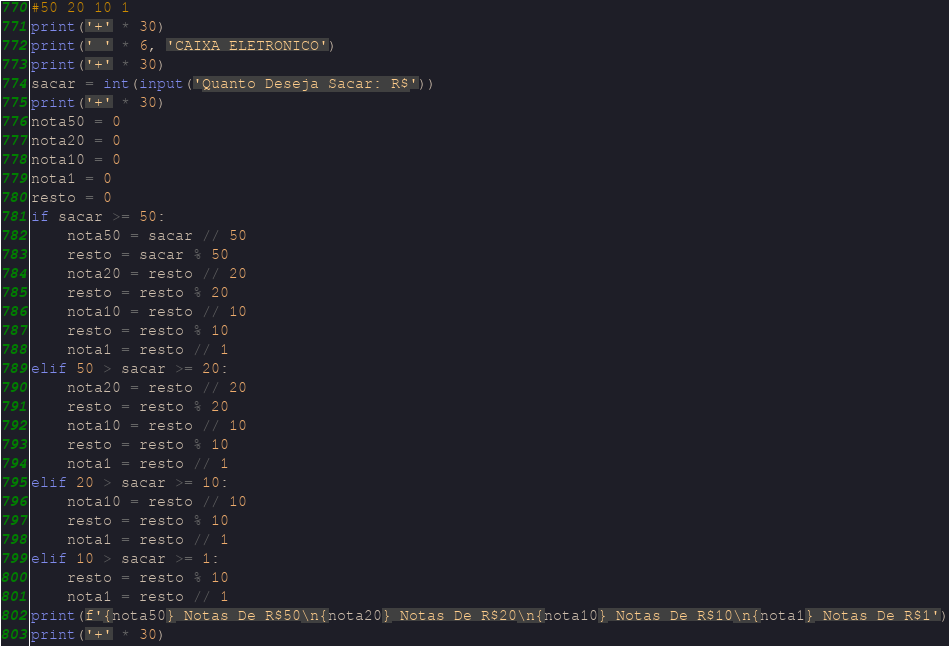<code> <loc_0><loc_0><loc_500><loc_500><_Python_>#50 20 10 1
print('+' * 30)
print(' ' * 6, 'CAIXA ELETRONICO')
print('+' * 30)
sacar = int(input('Quanto Deseja Sacar: R$'))
print('+' * 30)
nota50 = 0
nota20 = 0
nota10 = 0
nota1 = 0
resto = 0
if sacar >= 50:
    nota50 = sacar // 50
    resto = sacar % 50
    nota20 = resto // 20
    resto = resto % 20
    nota10 = resto // 10
    resto = resto % 10
    nota1 = resto // 1
elif 50 > sacar >= 20:
    nota20 = resto // 20
    resto = resto % 20
    nota10 = resto // 10
    resto = resto % 10
    nota1 = resto // 1
elif 20 > sacar >= 10:
    nota10 = resto // 10
    resto = resto % 10
    nota1 = resto // 1
elif 10 > sacar >= 1:
    resto = resto % 10
    nota1 = resto // 1
print(f'{nota50} Notas De R$50\n{nota20} Notas De R$20\n{nota10} Notas De R$10\n{nota1} Notas De R$1')
print('+' * 30)
</code> 